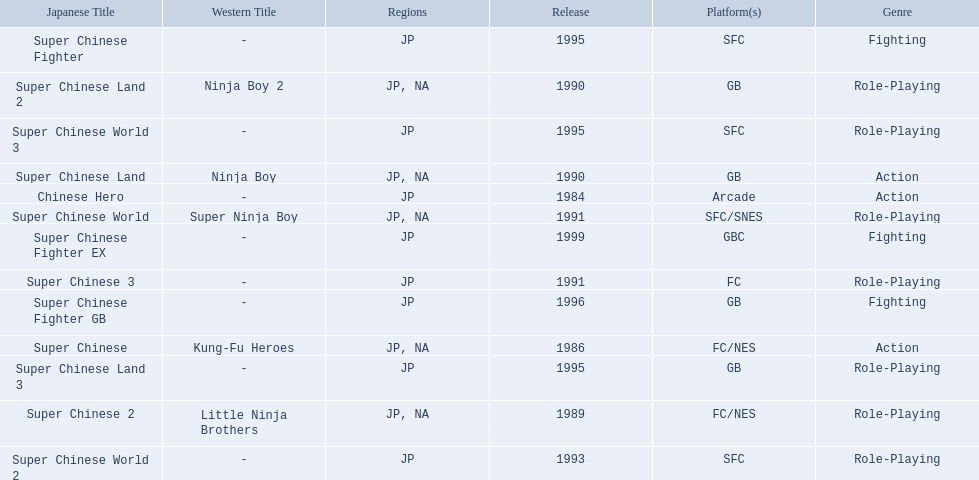Super ninja world was released in what countries? JP, NA. What was the original name for this title? Super Chinese World. 